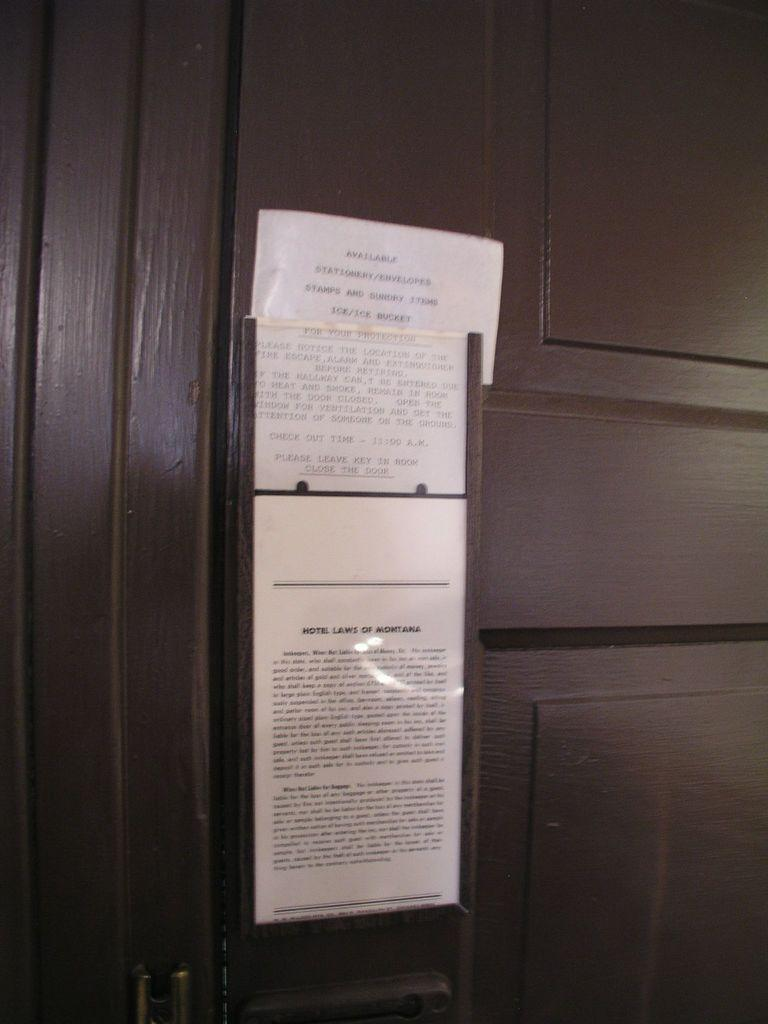<image>
Describe the image concisely. A wood door with signs saying "Available Stationery/Envelopes" 